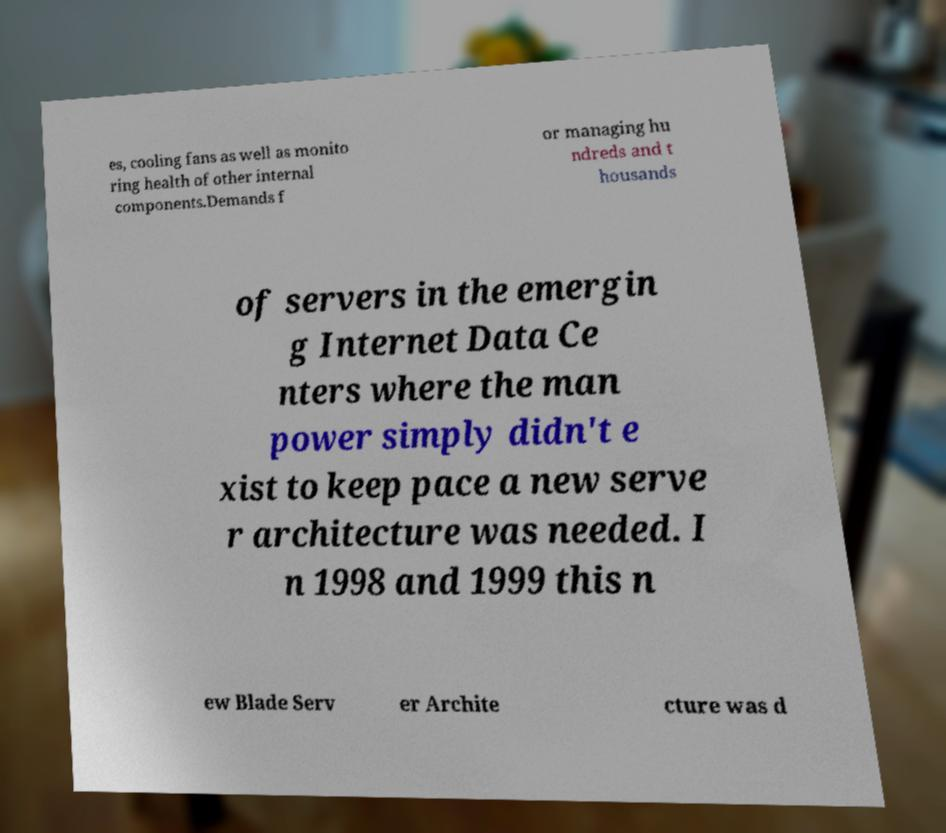Can you read and provide the text displayed in the image?This photo seems to have some interesting text. Can you extract and type it out for me? es, cooling fans as well as monito ring health of other internal components.Demands f or managing hu ndreds and t housands of servers in the emergin g Internet Data Ce nters where the man power simply didn't e xist to keep pace a new serve r architecture was needed. I n 1998 and 1999 this n ew Blade Serv er Archite cture was d 